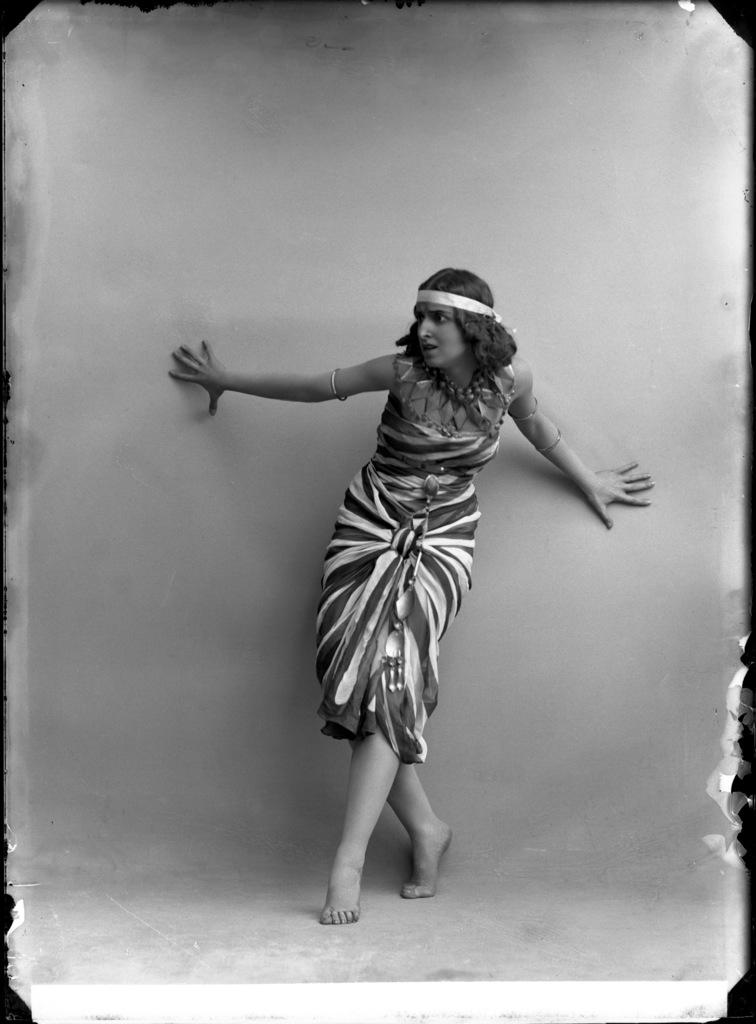Who is the main subject in the image? There is a woman in the image. Where is the woman located in the image? The woman is standing near a wall. Can you describe any editing done to the image? The image is edited. What type of drop can be seen falling from the woman's hand in the image? There is no drop visible in the image, as it is not mentioned in the provided facts. 